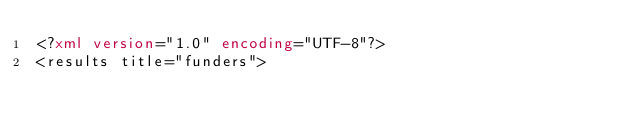<code> <loc_0><loc_0><loc_500><loc_500><_XML_><?xml version="1.0" encoding="UTF-8"?>
<results title="funders"></code> 